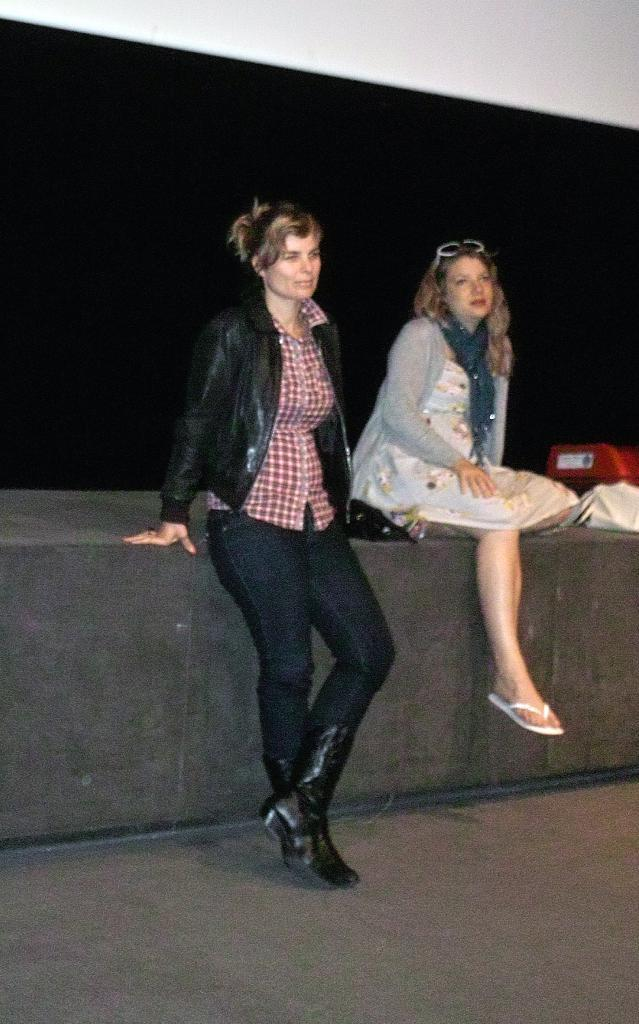How many women are present in the image? There are two women in the image, one standing and one sitting. What is the position of the sitting woman? The sitting woman is on a pavement. What can be seen in the background of the image? Walls are visible in the background of the image. What type of organization is the woman in the image a part of? There is no information about any organization in the image, as it only shows two women, one standing and one sitting on a pavement. Is the woman sitting in the image crying? There is no indication of any emotion, such as crying, in the image. 